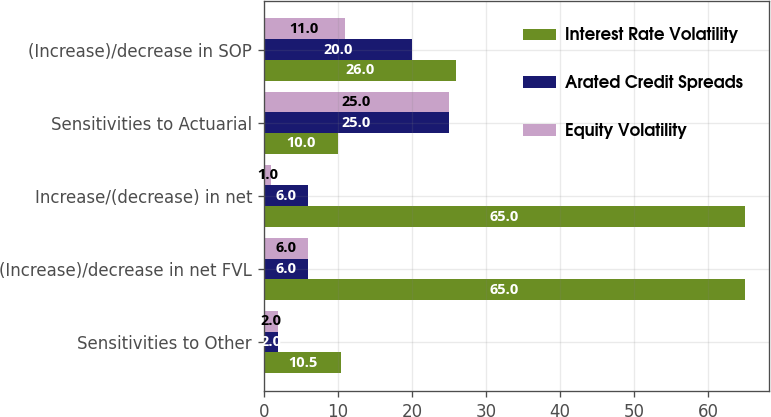Convert chart. <chart><loc_0><loc_0><loc_500><loc_500><stacked_bar_chart><ecel><fcel>Sensitivities to Other<fcel>(Increase)/decrease in net FVL<fcel>Increase/(decrease) in net<fcel>Sensitivities to Actuarial<fcel>(Increase)/decrease in SOP<nl><fcel>Interest Rate Volatility<fcel>10.5<fcel>65<fcel>65<fcel>10<fcel>26<nl><fcel>Arated Credit Spreads<fcel>2<fcel>6<fcel>6<fcel>25<fcel>20<nl><fcel>Equity Volatility<fcel>2<fcel>6<fcel>1<fcel>25<fcel>11<nl></chart> 